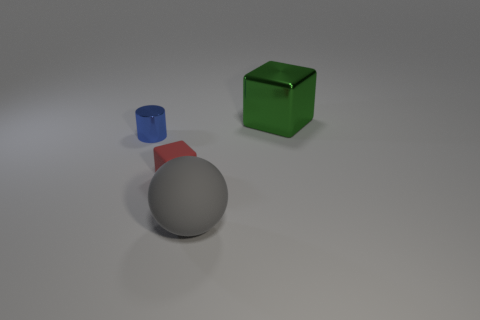What number of other objects are there of the same size as the cylinder?
Provide a succinct answer. 1. The shiny cylinder has what color?
Offer a terse response. Blue. What material is the big object right of the big matte sphere?
Your answer should be very brief. Metal. Are there an equal number of big objects that are on the left side of the gray thing and small blue metal things?
Ensure brevity in your answer.  No. Does the red matte object have the same shape as the blue shiny thing?
Your answer should be very brief. No. Is there anything else that is the same color as the big rubber object?
Your answer should be very brief. No. What is the shape of the object that is both on the left side of the big gray matte ball and to the right of the tiny cylinder?
Your response must be concise. Cube. Are there the same number of big balls behind the green thing and metal cubes in front of the small shiny object?
Your answer should be very brief. Yes. What number of blocks are either brown rubber things or big green objects?
Offer a very short reply. 1. What number of small blocks have the same material as the tiny cylinder?
Offer a very short reply. 0. 